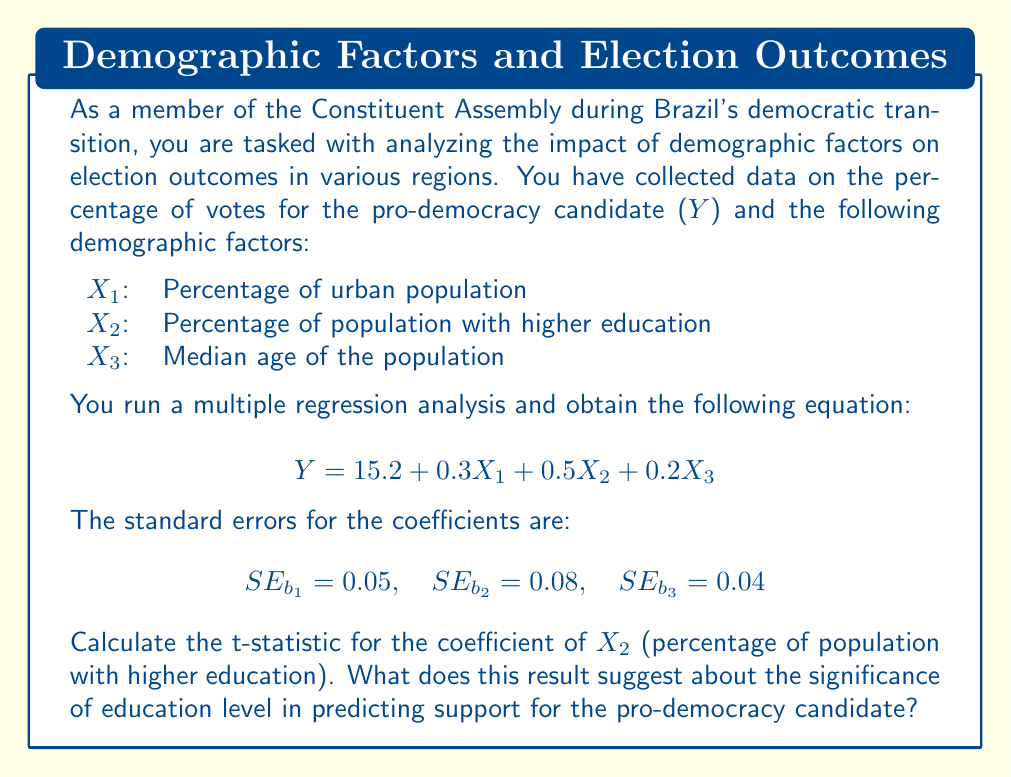Provide a solution to this math problem. To solve this problem, we need to follow these steps:

1. Identify the coefficient and standard error for $X_2$:
   - Coefficient ($b_2$) = 0.5
   - Standard error ($SE_{b_2}$) = 0.08

2. Calculate the t-statistic using the formula:
   $$t = \frac{b_k}{SE_{b_k}}$$
   Where $b_k$ is the coefficient and $SE_{b_k}$ is the standard error.

3. Substitute the values:
   $$t = \frac{0.5}{0.08} = 6.25$$

4. Interpret the result:
   - The t-statistic is used to determine the significance of the predictor variable.
   - Generally, a t-statistic with an absolute value greater than 2 is considered significant at the 0.05 level for large sample sizes.
   - Our t-statistic of 6.25 is much larger than 2, indicating that the percentage of population with higher education is a highly significant predictor of support for the pro-democracy candidate.

5. In the context of Brazil's democratic transition:
   - This result suggests that regions with higher levels of education tend to show stronger support for the pro-democracy candidate.
   - The positive coefficient (0.5) indicates that as the percentage of the population with higher education increases, the support for the pro-democracy candidate also increases.
   - This finding could be crucial for understanding the demographic factors influencing the democratic transition and could inform strategies for promoting democratic values.
Answer: The t-statistic for the coefficient of $X_2$ is 6.25. This high t-value suggests that the percentage of population with higher education is a statistically significant predictor of support for the pro-democracy candidate, with higher education levels associated with increased support for democracy. 